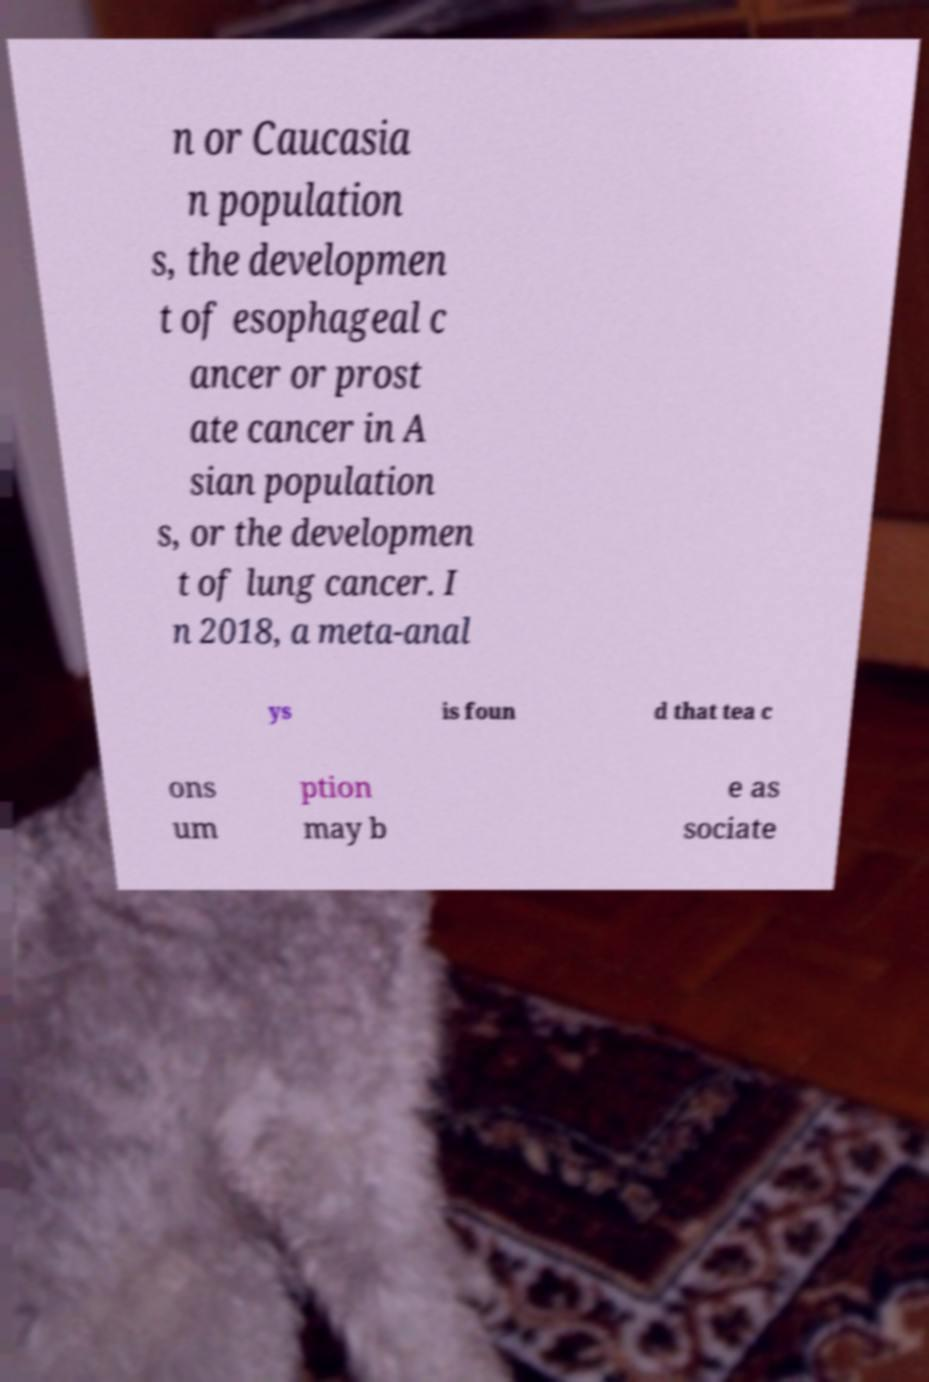Please identify and transcribe the text found in this image. n or Caucasia n population s, the developmen t of esophageal c ancer or prost ate cancer in A sian population s, or the developmen t of lung cancer. I n 2018, a meta-anal ys is foun d that tea c ons um ption may b e as sociate 